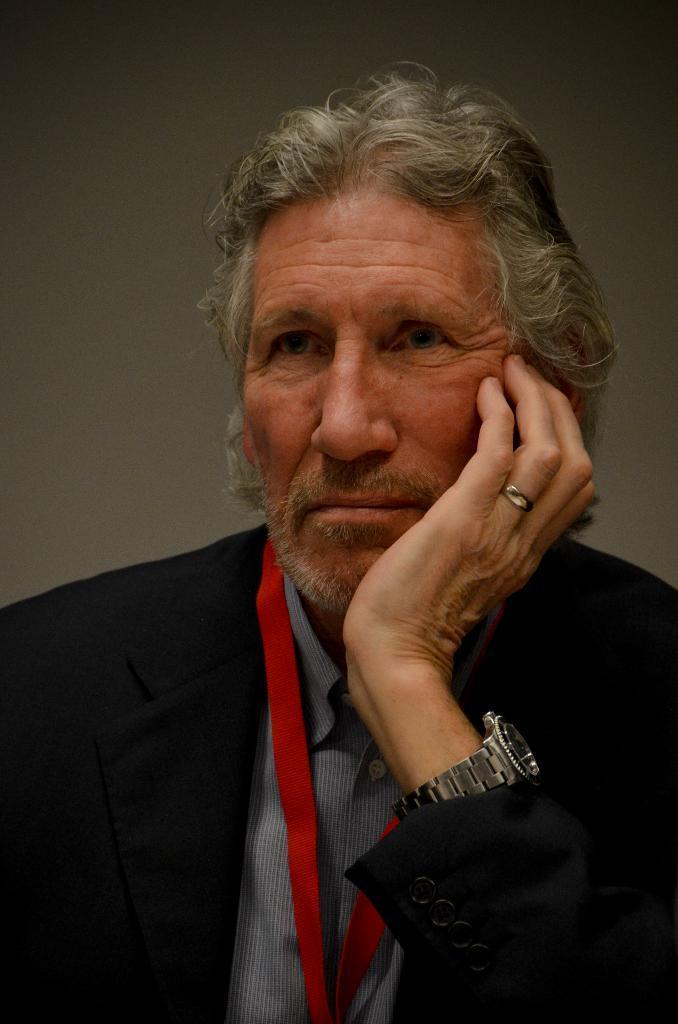Please provide a concise description of this image. In the picture there is a man, he is wearing a blazer and he kept his hand on his chin, behind the man there is a plain surface. 